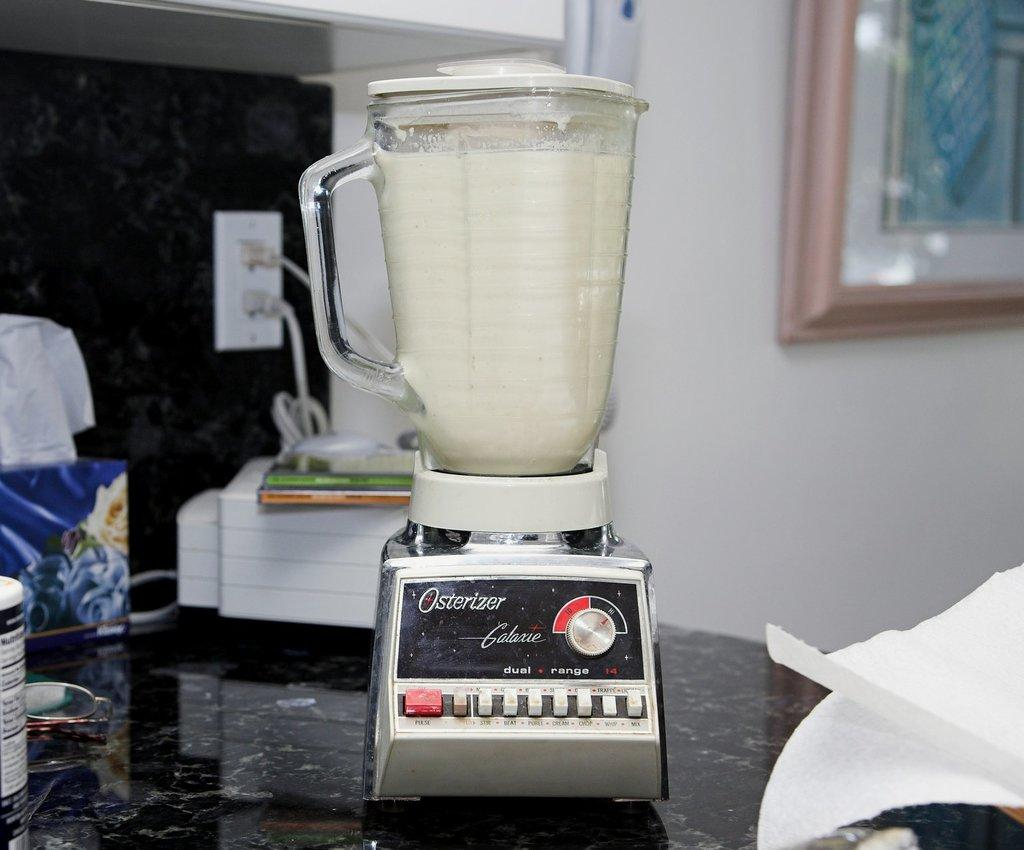<image>
Summarize the visual content of the image. An Osterizer blender sitting on the counter with a white substance in it similar to milk. 